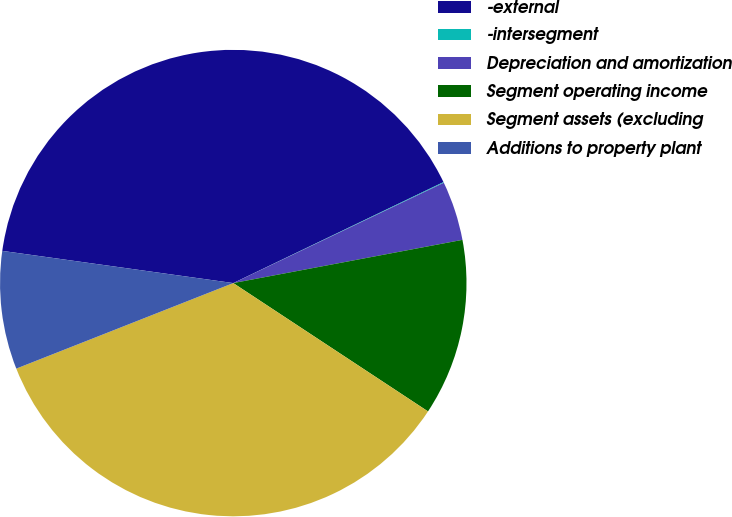Convert chart to OTSL. <chart><loc_0><loc_0><loc_500><loc_500><pie_chart><fcel>-external<fcel>-intersegment<fcel>Depreciation and amortization<fcel>Segment operating income<fcel>Segment assets (excluding<fcel>Additions to property plant<nl><fcel>40.67%<fcel>0.05%<fcel>4.11%<fcel>12.24%<fcel>34.75%<fcel>8.18%<nl></chart> 